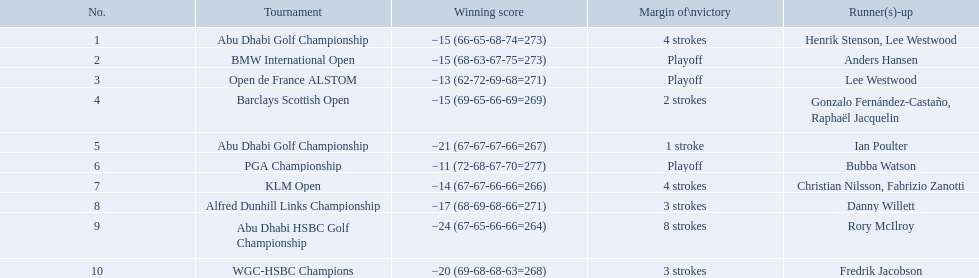What were the margins of victories of the tournaments? 4 strokes, Playoff, Playoff, 2 strokes, 1 stroke, Playoff, 4 strokes, 3 strokes, 8 strokes, 3 strokes. Of these, what was the margin of victory of the klm and the barklay 2 strokes, 4 strokes. What were the difference between these? 2 strokes. What were all the different tournaments played by martin kaymer Abu Dhabi Golf Championship, BMW International Open, Open de France ALSTOM, Barclays Scottish Open, Abu Dhabi Golf Championship, PGA Championship, KLM Open, Alfred Dunhill Links Championship, Abu Dhabi HSBC Golf Championship, WGC-HSBC Champions. Who was the runner-up for the pga championship? Bubba Watson. 